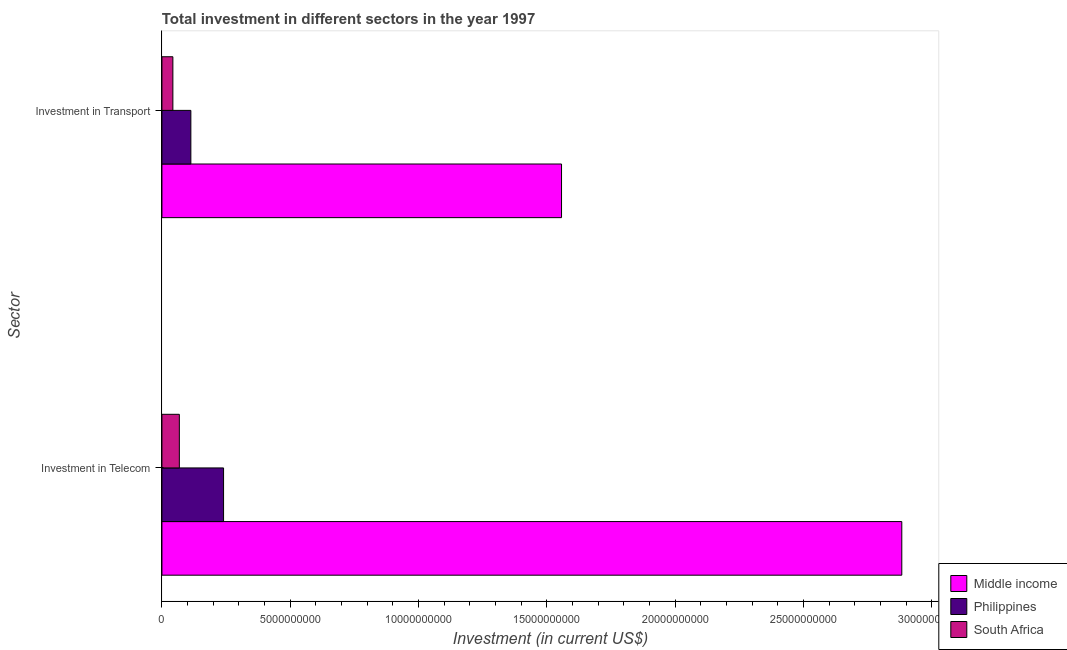Are the number of bars per tick equal to the number of legend labels?
Offer a terse response. Yes. How many bars are there on the 2nd tick from the top?
Your answer should be compact. 3. How many bars are there on the 1st tick from the bottom?
Ensure brevity in your answer.  3. What is the label of the 2nd group of bars from the top?
Keep it short and to the point. Investment in Telecom. What is the investment in telecom in Middle income?
Provide a short and direct response. 2.88e+1. Across all countries, what is the maximum investment in telecom?
Keep it short and to the point. 2.88e+1. Across all countries, what is the minimum investment in transport?
Your answer should be very brief. 4.26e+08. In which country was the investment in transport minimum?
Your response must be concise. South Africa. What is the total investment in transport in the graph?
Offer a terse response. 1.71e+1. What is the difference between the investment in telecom in Philippines and that in South Africa?
Provide a short and direct response. 1.72e+09. What is the difference between the investment in telecom in Philippines and the investment in transport in South Africa?
Offer a very short reply. 1.97e+09. What is the average investment in transport per country?
Provide a short and direct response. 5.71e+09. What is the difference between the investment in telecom and investment in transport in Middle income?
Keep it short and to the point. 1.33e+1. In how many countries, is the investment in transport greater than 27000000000 US$?
Ensure brevity in your answer.  0. What is the ratio of the investment in transport in South Africa to that in Middle income?
Offer a very short reply. 0.03. Is the investment in telecom in Philippines less than that in South Africa?
Offer a terse response. No. What does the 1st bar from the top in Investment in Transport represents?
Ensure brevity in your answer.  South Africa. How many bars are there?
Ensure brevity in your answer.  6. How many countries are there in the graph?
Keep it short and to the point. 3. What is the difference between two consecutive major ticks on the X-axis?
Make the answer very short. 5.00e+09. Are the values on the major ticks of X-axis written in scientific E-notation?
Your answer should be very brief. No. Does the graph contain any zero values?
Your answer should be very brief. No. How many legend labels are there?
Give a very brief answer. 3. What is the title of the graph?
Keep it short and to the point. Total investment in different sectors in the year 1997. What is the label or title of the X-axis?
Provide a short and direct response. Investment (in current US$). What is the label or title of the Y-axis?
Make the answer very short. Sector. What is the Investment (in current US$) in Middle income in Investment in Telecom?
Give a very brief answer. 2.88e+1. What is the Investment (in current US$) of Philippines in Investment in Telecom?
Ensure brevity in your answer.  2.40e+09. What is the Investment (in current US$) of South Africa in Investment in Telecom?
Make the answer very short. 6.78e+08. What is the Investment (in current US$) of Middle income in Investment in Transport?
Keep it short and to the point. 1.56e+1. What is the Investment (in current US$) in Philippines in Investment in Transport?
Keep it short and to the point. 1.13e+09. What is the Investment (in current US$) of South Africa in Investment in Transport?
Your answer should be very brief. 4.26e+08. Across all Sector, what is the maximum Investment (in current US$) of Middle income?
Offer a very short reply. 2.88e+1. Across all Sector, what is the maximum Investment (in current US$) of Philippines?
Offer a very short reply. 2.40e+09. Across all Sector, what is the maximum Investment (in current US$) of South Africa?
Offer a very short reply. 6.78e+08. Across all Sector, what is the minimum Investment (in current US$) of Middle income?
Provide a short and direct response. 1.56e+1. Across all Sector, what is the minimum Investment (in current US$) of Philippines?
Ensure brevity in your answer.  1.13e+09. Across all Sector, what is the minimum Investment (in current US$) of South Africa?
Offer a terse response. 4.26e+08. What is the total Investment (in current US$) of Middle income in the graph?
Offer a very short reply. 4.44e+1. What is the total Investment (in current US$) of Philippines in the graph?
Ensure brevity in your answer.  3.53e+09. What is the total Investment (in current US$) of South Africa in the graph?
Provide a short and direct response. 1.10e+09. What is the difference between the Investment (in current US$) in Middle income in Investment in Telecom and that in Investment in Transport?
Ensure brevity in your answer.  1.33e+1. What is the difference between the Investment (in current US$) in Philippines in Investment in Telecom and that in Investment in Transport?
Make the answer very short. 1.27e+09. What is the difference between the Investment (in current US$) in South Africa in Investment in Telecom and that in Investment in Transport?
Ensure brevity in your answer.  2.52e+08. What is the difference between the Investment (in current US$) in Middle income in Investment in Telecom and the Investment (in current US$) in Philippines in Investment in Transport?
Your response must be concise. 2.77e+1. What is the difference between the Investment (in current US$) in Middle income in Investment in Telecom and the Investment (in current US$) in South Africa in Investment in Transport?
Keep it short and to the point. 2.84e+1. What is the difference between the Investment (in current US$) of Philippines in Investment in Telecom and the Investment (in current US$) of South Africa in Investment in Transport?
Give a very brief answer. 1.97e+09. What is the average Investment (in current US$) of Middle income per Sector?
Make the answer very short. 2.22e+1. What is the average Investment (in current US$) in Philippines per Sector?
Your answer should be compact. 1.76e+09. What is the average Investment (in current US$) of South Africa per Sector?
Give a very brief answer. 5.52e+08. What is the difference between the Investment (in current US$) of Middle income and Investment (in current US$) of Philippines in Investment in Telecom?
Provide a succinct answer. 2.64e+1. What is the difference between the Investment (in current US$) of Middle income and Investment (in current US$) of South Africa in Investment in Telecom?
Keep it short and to the point. 2.81e+1. What is the difference between the Investment (in current US$) of Philippines and Investment (in current US$) of South Africa in Investment in Telecom?
Make the answer very short. 1.72e+09. What is the difference between the Investment (in current US$) of Middle income and Investment (in current US$) of Philippines in Investment in Transport?
Keep it short and to the point. 1.44e+1. What is the difference between the Investment (in current US$) of Middle income and Investment (in current US$) of South Africa in Investment in Transport?
Give a very brief answer. 1.51e+1. What is the difference between the Investment (in current US$) of Philippines and Investment (in current US$) of South Africa in Investment in Transport?
Provide a short and direct response. 7.01e+08. What is the ratio of the Investment (in current US$) of Middle income in Investment in Telecom to that in Investment in Transport?
Your response must be concise. 1.85. What is the ratio of the Investment (in current US$) in Philippines in Investment in Telecom to that in Investment in Transport?
Give a very brief answer. 2.13. What is the ratio of the Investment (in current US$) in South Africa in Investment in Telecom to that in Investment in Transport?
Your response must be concise. 1.59. What is the difference between the highest and the second highest Investment (in current US$) of Middle income?
Your answer should be compact. 1.33e+1. What is the difference between the highest and the second highest Investment (in current US$) of Philippines?
Your response must be concise. 1.27e+09. What is the difference between the highest and the second highest Investment (in current US$) in South Africa?
Provide a short and direct response. 2.52e+08. What is the difference between the highest and the lowest Investment (in current US$) of Middle income?
Keep it short and to the point. 1.33e+1. What is the difference between the highest and the lowest Investment (in current US$) of Philippines?
Ensure brevity in your answer.  1.27e+09. What is the difference between the highest and the lowest Investment (in current US$) of South Africa?
Your answer should be compact. 2.52e+08. 